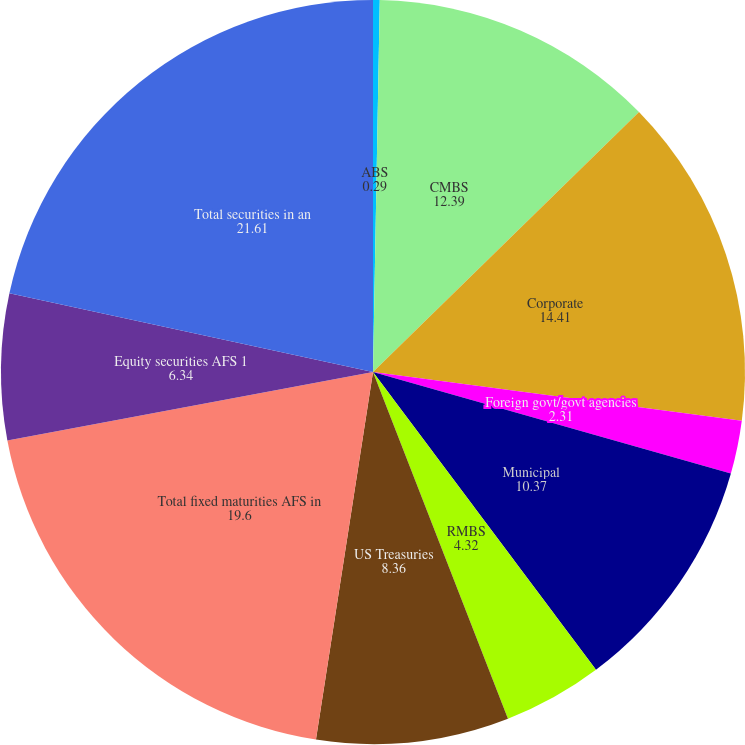<chart> <loc_0><loc_0><loc_500><loc_500><pie_chart><fcel>ABS<fcel>CMBS<fcel>Corporate<fcel>Foreign govt/govt agencies<fcel>Municipal<fcel>RMBS<fcel>US Treasuries<fcel>Total fixed maturities AFS in<fcel>Equity securities AFS 1<fcel>Total securities in an<nl><fcel>0.29%<fcel>12.39%<fcel>14.41%<fcel>2.31%<fcel>10.37%<fcel>4.32%<fcel>8.36%<fcel>19.6%<fcel>6.34%<fcel>21.61%<nl></chart> 